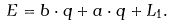<formula> <loc_0><loc_0><loc_500><loc_500>E = { b } \cdot { q } + { a } \cdot { q } + L _ { 1 } .</formula> 